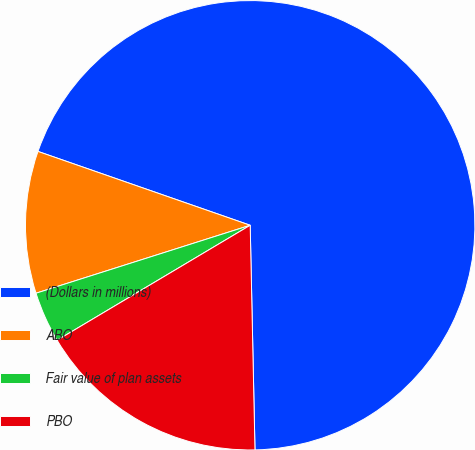Convert chart. <chart><loc_0><loc_0><loc_500><loc_500><pie_chart><fcel>(Dollars in millions)<fcel>ABO<fcel>Fair value of plan assets<fcel>PBO<nl><fcel>69.33%<fcel>10.22%<fcel>3.66%<fcel>16.79%<nl></chart> 